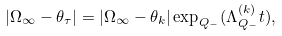<formula> <loc_0><loc_0><loc_500><loc_500>\left | \Omega _ { \infty } - \theta _ { \tau } \right | = \left | \Omega _ { \infty } - \theta _ { k } \right | \exp _ { Q _ { - } } ( \Lambda _ { Q _ { - } } ^ { ( k ) } t ) ,</formula> 